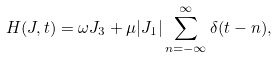Convert formula to latex. <formula><loc_0><loc_0><loc_500><loc_500>H ( { J } , t ) = \omega J _ { 3 } + \mu | J _ { 1 } | \sum _ { n = - \infty } ^ { \infty } \delta ( t - n ) ,</formula> 